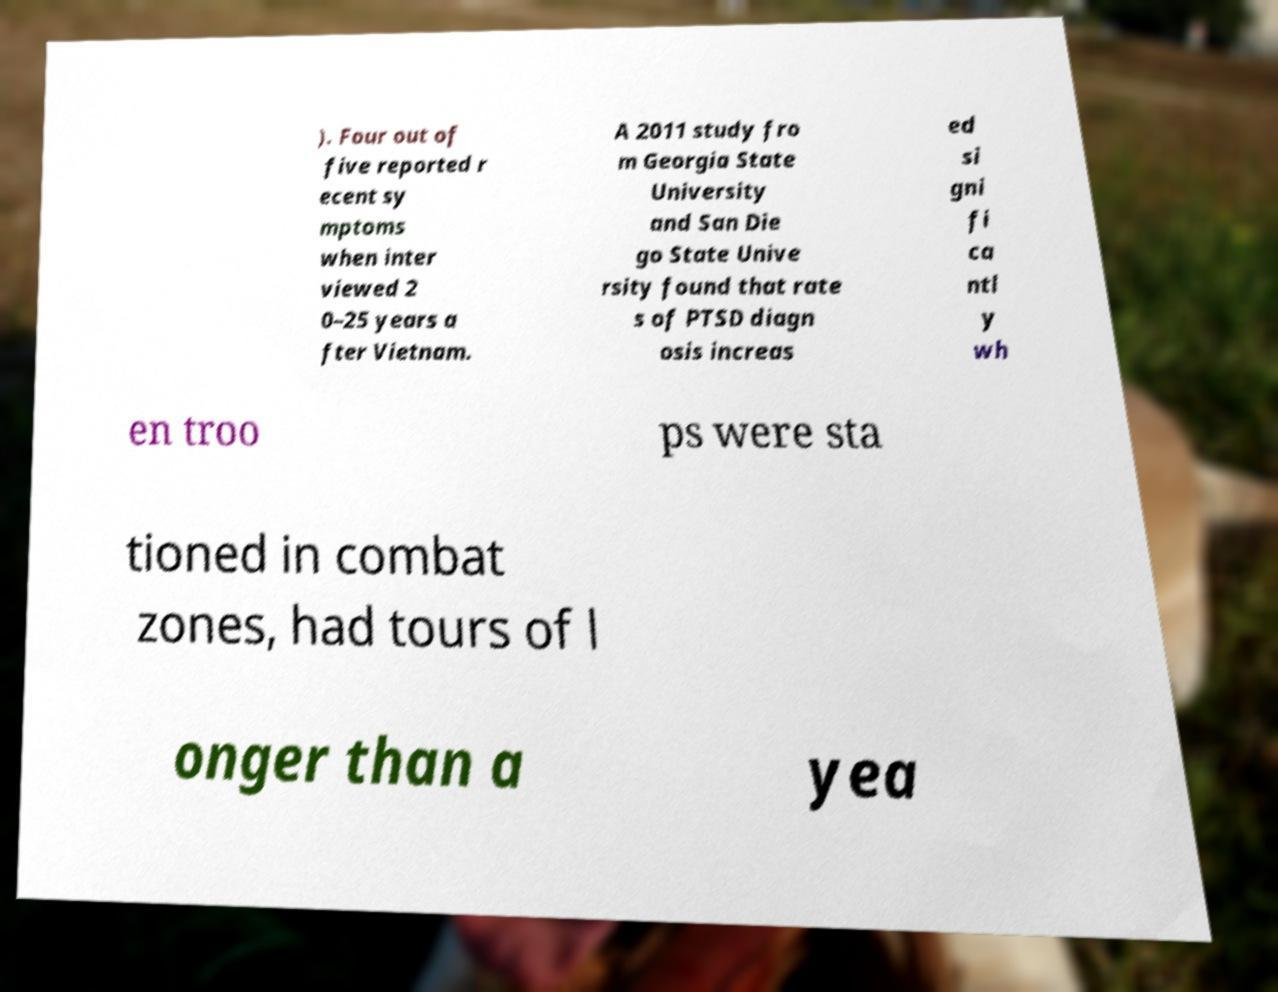For documentation purposes, I need the text within this image transcribed. Could you provide that? ). Four out of five reported r ecent sy mptoms when inter viewed 2 0–25 years a fter Vietnam. A 2011 study fro m Georgia State University and San Die go State Unive rsity found that rate s of PTSD diagn osis increas ed si gni fi ca ntl y wh en troo ps were sta tioned in combat zones, had tours of l onger than a yea 